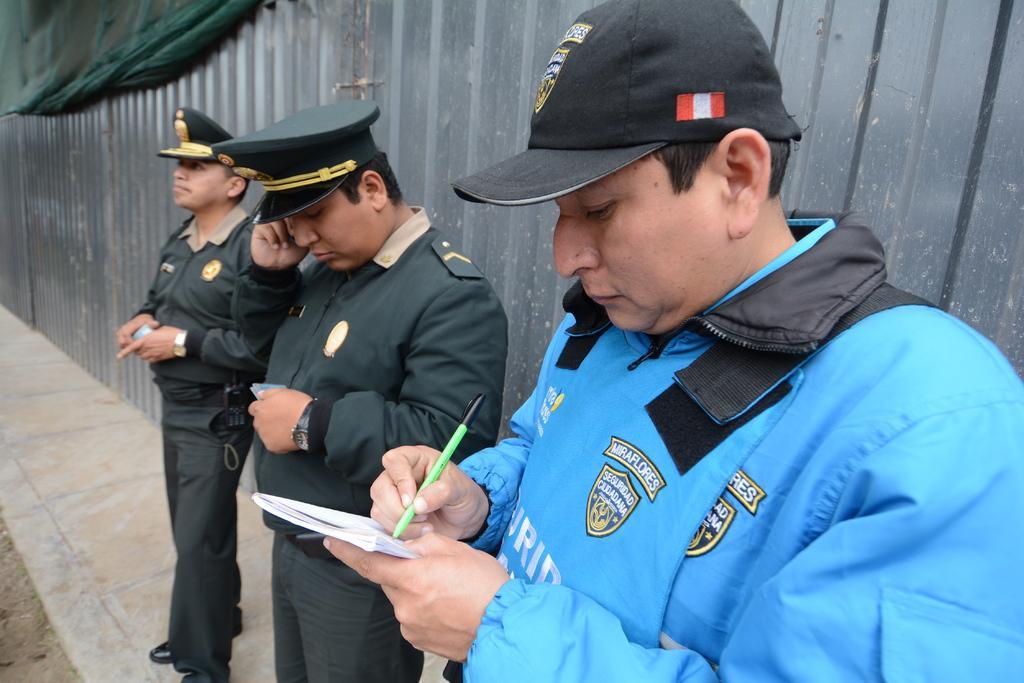Please provide a concise description of this image. In the image there are three officers standing in front of a fence made with a metal and the first person is writing something on a book. 